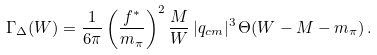<formula> <loc_0><loc_0><loc_500><loc_500>\Gamma _ { \Delta } ( W ) = { \frac { 1 } { 6 \pi } } \left ( { \frac { f ^ { * } } { m _ { \pi } } } \right ) ^ { 2 } { \frac { M } { W } } \, | { q _ { c m } } | ^ { 3 } \, \Theta ( W - M - m _ { \pi } ) \, .</formula> 